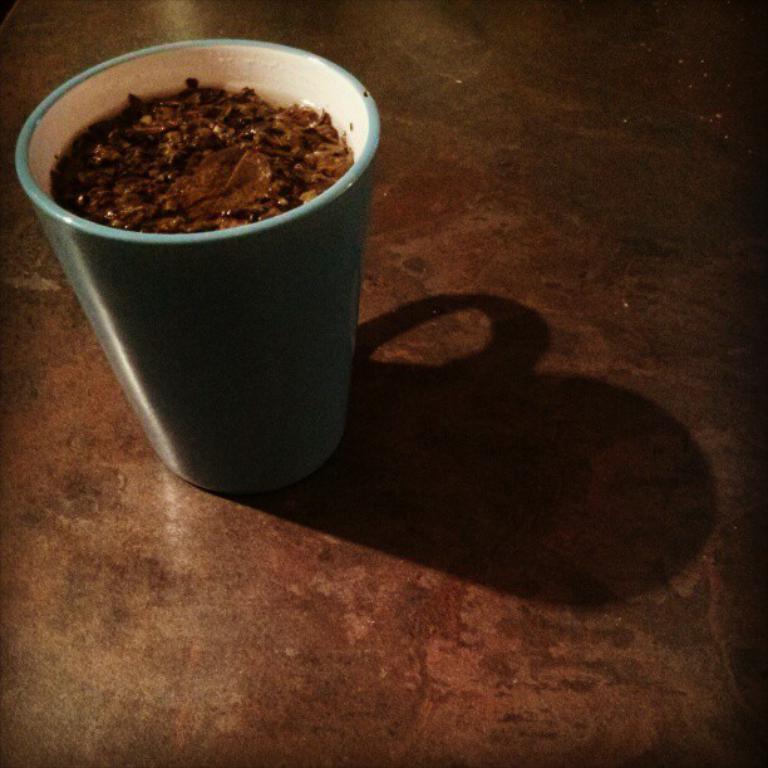Can you describe this image briefly? In this image a cup is filled with food. 